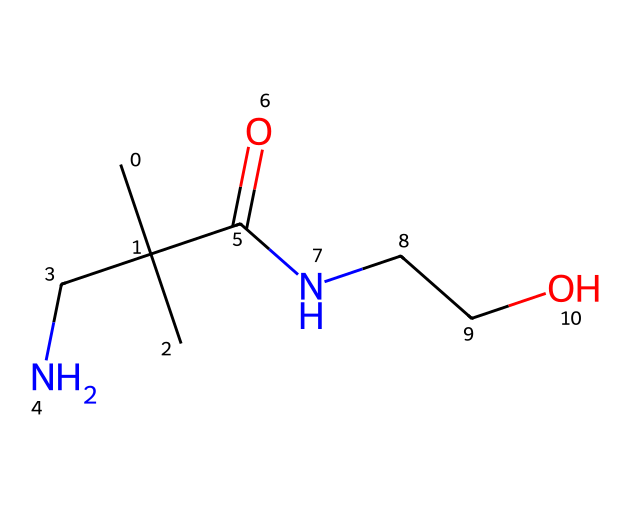What is the total number of carbon atoms in the chemical? The SMILES notation shows the structure contains four carbon (C) atoms represented as "CC(C)(C)", and the presence of the carbon atoms in the chain and branches adds up to a total of four.
Answer: four How many nitrogen atoms are present in the structure? Analyzing the SMILES representation, there are two nitrogen (N) atoms located in the structure, indicated by "N" in two separate positions.
Answer: two What functional group is present in this compound? The molecule contains an amide functional group, indicated by the "C(=O)N" in the SMILES, suggesting it is linked to both a carbonyl and an amine.
Answer: amide Does this compound contain any hydroxyl groups? The "CCO" portion of the SMILES signifies a hydroxyl group (-OH), indicating the presence of an alcohol in the chemical structure.
Answer: yes What type of polymer does this compound represent? Given the hydrophilic nature of the functional groups and their potential for water retention, this compound can be recognized as a hydrogel, which is a polymer that retains water.
Answer: hydrogel Why is this molecule likely to be used in medical technologies? The presence of both amide and hydroxyl functional groups contributes to its biocompatibility and ability to swell in biological environments, making it suitable for medical applications, especially in drug delivery and tissue engineering.
Answer: biocompatibility 